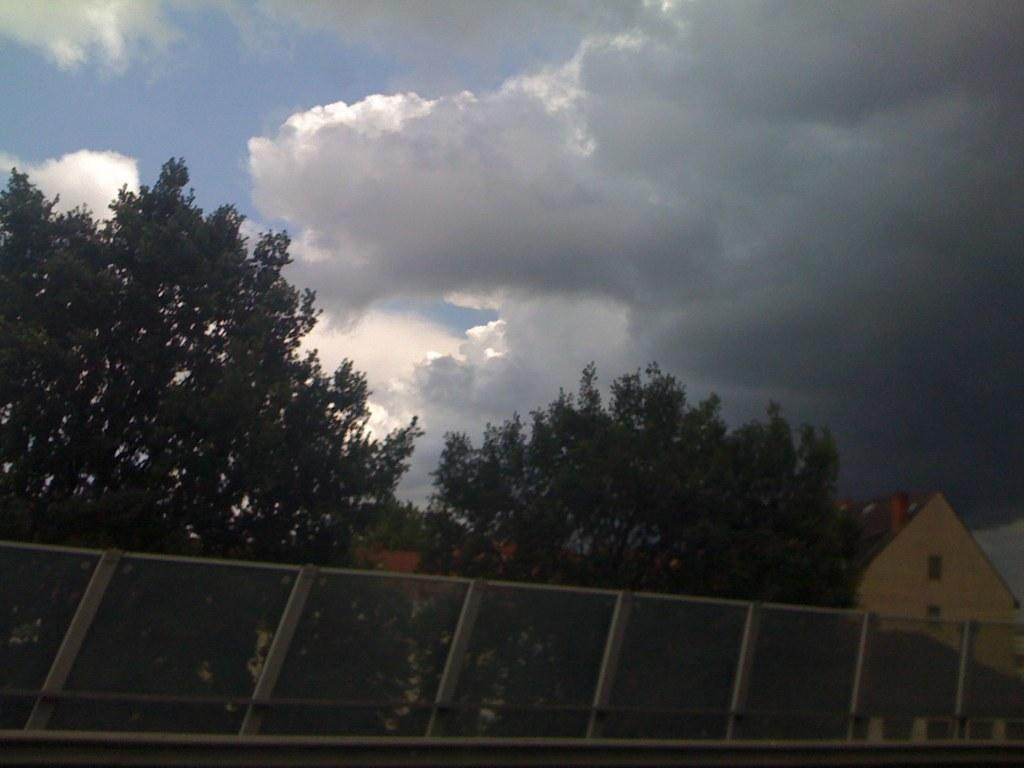What type of structures are located at the bottom of the image? There are houses at the bottom of the image. What object can be seen in the image that is typically used for catching or holding things? There is a net in the image. What type of vegetation is present in the image? There are trees in the image. What is visible at the top of the image? The sky is visible at the top of the image. How does the image show the decision made by the trees? The image does not show any decisions made by the trees, as trees do not make decisions. What type of respect can be seen in the image? There is no indication of respect in the image, as it only shows houses, a net, trees, and the sky. 